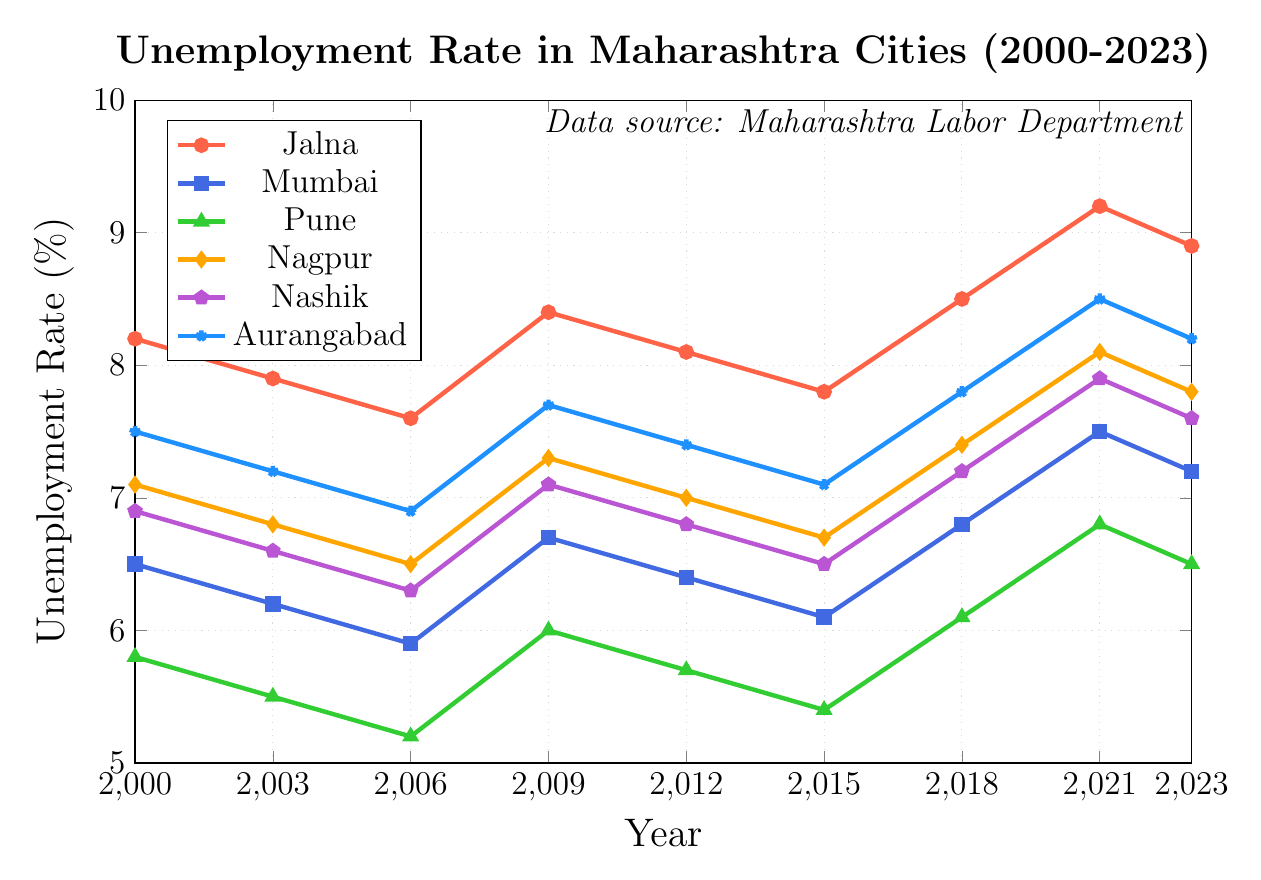What was the highest unemployment rate for Jalna during the period 2000 to 2023? To find the highest unemployment rate for Jalna, locate the highest point of the Jalna line (which is red) on the graph. The highest point is at 2021 with a rate of 9.2%.
Answer: 9.2% Which city had the lowest unemployment rate in 2006? Compare the markers for all cities in 2006. The lowest point among them is Pune with an unemployment rate of 5.2%.
Answer: Pune How does the unemployment rate change in Mumbai from 2000 to 2023? Observe the blue line representing Mumbai across the years. The rate decreased from 2000 (6.5%) to a low in 2006 (5.9%), then increased gradually, peaking in 2021 at 7.5% before slightly falling to 7.2% in 2023.
Answer: Decreases initially, then increases What is the difference in unemployment rates between Jalna and Aurangabad in 2018? Compare the markers for Jalna and Aurangabad in 2018. Jalna has a rate of 8.5% and Aurangabad has a rate of 7.8%. Calculate the difference: 8.5% - 7.8% = 0.7%.
Answer: 0.7% What is the average unemployment rate for Jalna over the period 2000-2023? Sum the unemployment rates for Jalna across all years and then divide by the number of years: (8.2 + 7.9 + 7.6 + 8.4 + 8.1 + 7.8 + 8.5 + 9.2 + 8.9) / 9 = 75.6 / 9 ≈ 8.4%.
Answer: 8.4% Between Nashik and Nagpur, which city had a higher unemployment rate in 2021? Compare the markers for Nashik and Nagpur in 2021. Nashik’s unemployment rate is 7.9%, while Nagpur’s is 8.1%.
Answer: Nagpur What is the trend of the unemployment rate in Aurangabad from 2000 to 2023? Observe the line for Aurangabad. It starts at 7.5% in 2000, decreases to 6.9% in 2006, then generally increases and reaches 8.2% in 2023.
Answer: Decreases initially, then increases Which year did Jalna have the greatest decrease in unemployment rate? Compare the markers for Jalna across the years. The greatest decrease is from 2021 (9.2%) to 2023 (8.9%), a reduction of 0.3%.
Answer: 2021 to 2023 